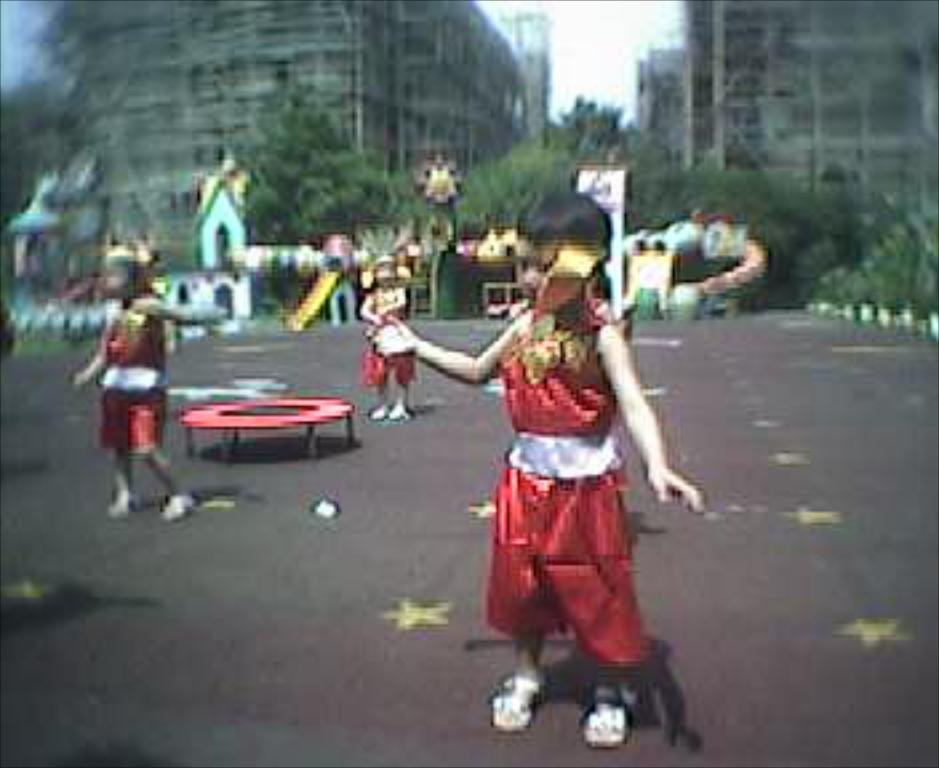What is happening in the image? There are people standing in the image. Can you describe the red object in the image? There is a red object that looks like a table in the image. What can be seen in the background of the image? There are buildings, trees, and the sky visible in the background of the image. How many squirrels are playing on the lake in the image? There is no lake or squirrels present in the image. What type of cars can be seen driving in the background of the image? There are no cars visible in the image; only buildings, trees, and the sky are present in the background. 